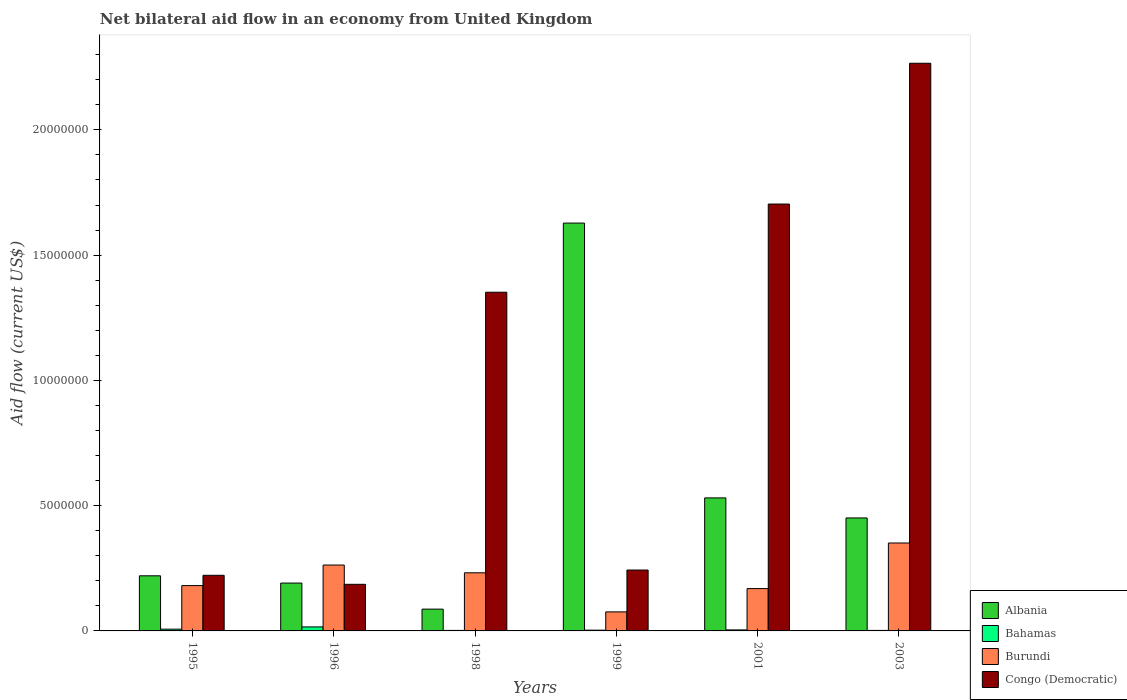How many different coloured bars are there?
Your answer should be compact. 4. Are the number of bars per tick equal to the number of legend labels?
Ensure brevity in your answer.  Yes. Are the number of bars on each tick of the X-axis equal?
Ensure brevity in your answer.  Yes. In how many cases, is the number of bars for a given year not equal to the number of legend labels?
Offer a terse response. 0. What is the net bilateral aid flow in Congo (Democratic) in 1995?
Provide a succinct answer. 2.22e+06. Across all years, what is the maximum net bilateral aid flow in Burundi?
Provide a succinct answer. 3.51e+06. Across all years, what is the minimum net bilateral aid flow in Albania?
Keep it short and to the point. 8.70e+05. In which year was the net bilateral aid flow in Bahamas maximum?
Give a very brief answer. 1996. In which year was the net bilateral aid flow in Burundi minimum?
Offer a terse response. 1999. What is the total net bilateral aid flow in Albania in the graph?
Ensure brevity in your answer.  3.11e+07. What is the difference between the net bilateral aid flow in Bahamas in 1998 and that in 2003?
Your answer should be compact. 0. What is the difference between the net bilateral aid flow in Bahamas in 1998 and the net bilateral aid flow in Congo (Democratic) in 1995?
Give a very brief answer. -2.20e+06. What is the average net bilateral aid flow in Congo (Democratic) per year?
Offer a terse response. 9.96e+06. In the year 1999, what is the difference between the net bilateral aid flow in Congo (Democratic) and net bilateral aid flow in Burundi?
Your answer should be compact. 1.67e+06. In how many years, is the net bilateral aid flow in Congo (Democratic) greater than 18000000 US$?
Your response must be concise. 1. What is the ratio of the net bilateral aid flow in Bahamas in 1999 to that in 2001?
Give a very brief answer. 0.75. Is the net bilateral aid flow in Congo (Democratic) in 1995 less than that in 1996?
Offer a very short reply. No. Is the difference between the net bilateral aid flow in Congo (Democratic) in 1995 and 2001 greater than the difference between the net bilateral aid flow in Burundi in 1995 and 2001?
Give a very brief answer. No. What is the difference between the highest and the lowest net bilateral aid flow in Burundi?
Your answer should be very brief. 2.75e+06. In how many years, is the net bilateral aid flow in Burundi greater than the average net bilateral aid flow in Burundi taken over all years?
Provide a short and direct response. 3. Is the sum of the net bilateral aid flow in Albania in 1995 and 2003 greater than the maximum net bilateral aid flow in Congo (Democratic) across all years?
Make the answer very short. No. What does the 2nd bar from the left in 2003 represents?
Your answer should be very brief. Bahamas. What does the 3rd bar from the right in 1998 represents?
Provide a short and direct response. Bahamas. How many bars are there?
Make the answer very short. 24. Are all the bars in the graph horizontal?
Offer a terse response. No. How many years are there in the graph?
Your response must be concise. 6. What is the difference between two consecutive major ticks on the Y-axis?
Your response must be concise. 5.00e+06. Are the values on the major ticks of Y-axis written in scientific E-notation?
Give a very brief answer. No. Does the graph contain any zero values?
Keep it short and to the point. No. Does the graph contain grids?
Keep it short and to the point. No. What is the title of the graph?
Make the answer very short. Net bilateral aid flow in an economy from United Kingdom. What is the label or title of the X-axis?
Offer a terse response. Years. What is the Aid flow (current US$) of Albania in 1995?
Make the answer very short. 2.20e+06. What is the Aid flow (current US$) of Bahamas in 1995?
Provide a succinct answer. 7.00e+04. What is the Aid flow (current US$) of Burundi in 1995?
Offer a terse response. 1.81e+06. What is the Aid flow (current US$) in Congo (Democratic) in 1995?
Keep it short and to the point. 2.22e+06. What is the Aid flow (current US$) in Albania in 1996?
Offer a very short reply. 1.91e+06. What is the Aid flow (current US$) in Burundi in 1996?
Offer a terse response. 2.63e+06. What is the Aid flow (current US$) in Congo (Democratic) in 1996?
Make the answer very short. 1.86e+06. What is the Aid flow (current US$) of Albania in 1998?
Provide a short and direct response. 8.70e+05. What is the Aid flow (current US$) in Burundi in 1998?
Provide a succinct answer. 2.32e+06. What is the Aid flow (current US$) in Congo (Democratic) in 1998?
Provide a succinct answer. 1.35e+07. What is the Aid flow (current US$) of Albania in 1999?
Ensure brevity in your answer.  1.63e+07. What is the Aid flow (current US$) in Burundi in 1999?
Your response must be concise. 7.60e+05. What is the Aid flow (current US$) of Congo (Democratic) in 1999?
Your response must be concise. 2.43e+06. What is the Aid flow (current US$) of Albania in 2001?
Ensure brevity in your answer.  5.31e+06. What is the Aid flow (current US$) in Bahamas in 2001?
Your answer should be compact. 4.00e+04. What is the Aid flow (current US$) in Burundi in 2001?
Your answer should be compact. 1.69e+06. What is the Aid flow (current US$) of Congo (Democratic) in 2001?
Offer a terse response. 1.70e+07. What is the Aid flow (current US$) of Albania in 2003?
Your answer should be very brief. 4.51e+06. What is the Aid flow (current US$) of Burundi in 2003?
Your answer should be very brief. 3.51e+06. What is the Aid flow (current US$) of Congo (Democratic) in 2003?
Give a very brief answer. 2.27e+07. Across all years, what is the maximum Aid flow (current US$) in Albania?
Provide a short and direct response. 1.63e+07. Across all years, what is the maximum Aid flow (current US$) of Burundi?
Offer a very short reply. 3.51e+06. Across all years, what is the maximum Aid flow (current US$) of Congo (Democratic)?
Provide a short and direct response. 2.27e+07. Across all years, what is the minimum Aid flow (current US$) in Albania?
Your response must be concise. 8.70e+05. Across all years, what is the minimum Aid flow (current US$) of Burundi?
Offer a terse response. 7.60e+05. Across all years, what is the minimum Aid flow (current US$) in Congo (Democratic)?
Give a very brief answer. 1.86e+06. What is the total Aid flow (current US$) in Albania in the graph?
Your response must be concise. 3.11e+07. What is the total Aid flow (current US$) of Bahamas in the graph?
Ensure brevity in your answer.  3.40e+05. What is the total Aid flow (current US$) in Burundi in the graph?
Make the answer very short. 1.27e+07. What is the total Aid flow (current US$) in Congo (Democratic) in the graph?
Offer a very short reply. 5.97e+07. What is the difference between the Aid flow (current US$) in Bahamas in 1995 and that in 1996?
Make the answer very short. -9.00e+04. What is the difference between the Aid flow (current US$) of Burundi in 1995 and that in 1996?
Make the answer very short. -8.20e+05. What is the difference between the Aid flow (current US$) in Congo (Democratic) in 1995 and that in 1996?
Give a very brief answer. 3.60e+05. What is the difference between the Aid flow (current US$) in Albania in 1995 and that in 1998?
Provide a short and direct response. 1.33e+06. What is the difference between the Aid flow (current US$) in Burundi in 1995 and that in 1998?
Ensure brevity in your answer.  -5.10e+05. What is the difference between the Aid flow (current US$) of Congo (Democratic) in 1995 and that in 1998?
Your response must be concise. -1.13e+07. What is the difference between the Aid flow (current US$) in Albania in 1995 and that in 1999?
Keep it short and to the point. -1.41e+07. What is the difference between the Aid flow (current US$) of Bahamas in 1995 and that in 1999?
Give a very brief answer. 4.00e+04. What is the difference between the Aid flow (current US$) in Burundi in 1995 and that in 1999?
Your response must be concise. 1.05e+06. What is the difference between the Aid flow (current US$) in Albania in 1995 and that in 2001?
Offer a very short reply. -3.11e+06. What is the difference between the Aid flow (current US$) in Congo (Democratic) in 1995 and that in 2001?
Your answer should be compact. -1.48e+07. What is the difference between the Aid flow (current US$) of Albania in 1995 and that in 2003?
Provide a succinct answer. -2.31e+06. What is the difference between the Aid flow (current US$) of Bahamas in 1995 and that in 2003?
Your answer should be compact. 5.00e+04. What is the difference between the Aid flow (current US$) in Burundi in 1995 and that in 2003?
Give a very brief answer. -1.70e+06. What is the difference between the Aid flow (current US$) in Congo (Democratic) in 1995 and that in 2003?
Your answer should be very brief. -2.04e+07. What is the difference between the Aid flow (current US$) in Albania in 1996 and that in 1998?
Your answer should be compact. 1.04e+06. What is the difference between the Aid flow (current US$) of Congo (Democratic) in 1996 and that in 1998?
Offer a terse response. -1.17e+07. What is the difference between the Aid flow (current US$) of Albania in 1996 and that in 1999?
Your response must be concise. -1.44e+07. What is the difference between the Aid flow (current US$) of Burundi in 1996 and that in 1999?
Offer a terse response. 1.87e+06. What is the difference between the Aid flow (current US$) of Congo (Democratic) in 1996 and that in 1999?
Offer a very short reply. -5.70e+05. What is the difference between the Aid flow (current US$) of Albania in 1996 and that in 2001?
Provide a short and direct response. -3.40e+06. What is the difference between the Aid flow (current US$) in Burundi in 1996 and that in 2001?
Your answer should be very brief. 9.40e+05. What is the difference between the Aid flow (current US$) in Congo (Democratic) in 1996 and that in 2001?
Give a very brief answer. -1.52e+07. What is the difference between the Aid flow (current US$) in Albania in 1996 and that in 2003?
Give a very brief answer. -2.60e+06. What is the difference between the Aid flow (current US$) in Bahamas in 1996 and that in 2003?
Ensure brevity in your answer.  1.40e+05. What is the difference between the Aid flow (current US$) in Burundi in 1996 and that in 2003?
Your answer should be very brief. -8.80e+05. What is the difference between the Aid flow (current US$) of Congo (Democratic) in 1996 and that in 2003?
Your response must be concise. -2.08e+07. What is the difference between the Aid flow (current US$) of Albania in 1998 and that in 1999?
Provide a short and direct response. -1.54e+07. What is the difference between the Aid flow (current US$) of Burundi in 1998 and that in 1999?
Provide a succinct answer. 1.56e+06. What is the difference between the Aid flow (current US$) in Congo (Democratic) in 1998 and that in 1999?
Keep it short and to the point. 1.11e+07. What is the difference between the Aid flow (current US$) in Albania in 1998 and that in 2001?
Your response must be concise. -4.44e+06. What is the difference between the Aid flow (current US$) of Burundi in 1998 and that in 2001?
Give a very brief answer. 6.30e+05. What is the difference between the Aid flow (current US$) of Congo (Democratic) in 1998 and that in 2001?
Make the answer very short. -3.52e+06. What is the difference between the Aid flow (current US$) of Albania in 1998 and that in 2003?
Your answer should be very brief. -3.64e+06. What is the difference between the Aid flow (current US$) in Bahamas in 1998 and that in 2003?
Offer a very short reply. 0. What is the difference between the Aid flow (current US$) in Burundi in 1998 and that in 2003?
Make the answer very short. -1.19e+06. What is the difference between the Aid flow (current US$) of Congo (Democratic) in 1998 and that in 2003?
Provide a succinct answer. -9.14e+06. What is the difference between the Aid flow (current US$) in Albania in 1999 and that in 2001?
Give a very brief answer. 1.10e+07. What is the difference between the Aid flow (current US$) in Bahamas in 1999 and that in 2001?
Ensure brevity in your answer.  -10000. What is the difference between the Aid flow (current US$) in Burundi in 1999 and that in 2001?
Give a very brief answer. -9.30e+05. What is the difference between the Aid flow (current US$) of Congo (Democratic) in 1999 and that in 2001?
Your answer should be compact. -1.46e+07. What is the difference between the Aid flow (current US$) in Albania in 1999 and that in 2003?
Provide a short and direct response. 1.18e+07. What is the difference between the Aid flow (current US$) of Burundi in 1999 and that in 2003?
Make the answer very short. -2.75e+06. What is the difference between the Aid flow (current US$) of Congo (Democratic) in 1999 and that in 2003?
Keep it short and to the point. -2.02e+07. What is the difference between the Aid flow (current US$) of Albania in 2001 and that in 2003?
Provide a succinct answer. 8.00e+05. What is the difference between the Aid flow (current US$) of Bahamas in 2001 and that in 2003?
Offer a very short reply. 2.00e+04. What is the difference between the Aid flow (current US$) of Burundi in 2001 and that in 2003?
Your answer should be very brief. -1.82e+06. What is the difference between the Aid flow (current US$) in Congo (Democratic) in 2001 and that in 2003?
Your response must be concise. -5.62e+06. What is the difference between the Aid flow (current US$) of Albania in 1995 and the Aid flow (current US$) of Bahamas in 1996?
Keep it short and to the point. 2.04e+06. What is the difference between the Aid flow (current US$) in Albania in 1995 and the Aid flow (current US$) in Burundi in 1996?
Offer a very short reply. -4.30e+05. What is the difference between the Aid flow (current US$) of Bahamas in 1995 and the Aid flow (current US$) of Burundi in 1996?
Keep it short and to the point. -2.56e+06. What is the difference between the Aid flow (current US$) of Bahamas in 1995 and the Aid flow (current US$) of Congo (Democratic) in 1996?
Your response must be concise. -1.79e+06. What is the difference between the Aid flow (current US$) in Burundi in 1995 and the Aid flow (current US$) in Congo (Democratic) in 1996?
Provide a short and direct response. -5.00e+04. What is the difference between the Aid flow (current US$) in Albania in 1995 and the Aid flow (current US$) in Bahamas in 1998?
Your response must be concise. 2.18e+06. What is the difference between the Aid flow (current US$) of Albania in 1995 and the Aid flow (current US$) of Burundi in 1998?
Provide a short and direct response. -1.20e+05. What is the difference between the Aid flow (current US$) in Albania in 1995 and the Aid flow (current US$) in Congo (Democratic) in 1998?
Ensure brevity in your answer.  -1.13e+07. What is the difference between the Aid flow (current US$) in Bahamas in 1995 and the Aid flow (current US$) in Burundi in 1998?
Offer a very short reply. -2.25e+06. What is the difference between the Aid flow (current US$) in Bahamas in 1995 and the Aid flow (current US$) in Congo (Democratic) in 1998?
Your response must be concise. -1.34e+07. What is the difference between the Aid flow (current US$) of Burundi in 1995 and the Aid flow (current US$) of Congo (Democratic) in 1998?
Your answer should be compact. -1.17e+07. What is the difference between the Aid flow (current US$) of Albania in 1995 and the Aid flow (current US$) of Bahamas in 1999?
Keep it short and to the point. 2.17e+06. What is the difference between the Aid flow (current US$) in Albania in 1995 and the Aid flow (current US$) in Burundi in 1999?
Your response must be concise. 1.44e+06. What is the difference between the Aid flow (current US$) of Bahamas in 1995 and the Aid flow (current US$) of Burundi in 1999?
Provide a succinct answer. -6.90e+05. What is the difference between the Aid flow (current US$) in Bahamas in 1995 and the Aid flow (current US$) in Congo (Democratic) in 1999?
Provide a succinct answer. -2.36e+06. What is the difference between the Aid flow (current US$) in Burundi in 1995 and the Aid flow (current US$) in Congo (Democratic) in 1999?
Offer a terse response. -6.20e+05. What is the difference between the Aid flow (current US$) in Albania in 1995 and the Aid flow (current US$) in Bahamas in 2001?
Provide a succinct answer. 2.16e+06. What is the difference between the Aid flow (current US$) in Albania in 1995 and the Aid flow (current US$) in Burundi in 2001?
Give a very brief answer. 5.10e+05. What is the difference between the Aid flow (current US$) of Albania in 1995 and the Aid flow (current US$) of Congo (Democratic) in 2001?
Your answer should be compact. -1.48e+07. What is the difference between the Aid flow (current US$) of Bahamas in 1995 and the Aid flow (current US$) of Burundi in 2001?
Offer a very short reply. -1.62e+06. What is the difference between the Aid flow (current US$) in Bahamas in 1995 and the Aid flow (current US$) in Congo (Democratic) in 2001?
Provide a short and direct response. -1.70e+07. What is the difference between the Aid flow (current US$) of Burundi in 1995 and the Aid flow (current US$) of Congo (Democratic) in 2001?
Offer a very short reply. -1.52e+07. What is the difference between the Aid flow (current US$) in Albania in 1995 and the Aid flow (current US$) in Bahamas in 2003?
Offer a very short reply. 2.18e+06. What is the difference between the Aid flow (current US$) in Albania in 1995 and the Aid flow (current US$) in Burundi in 2003?
Ensure brevity in your answer.  -1.31e+06. What is the difference between the Aid flow (current US$) of Albania in 1995 and the Aid flow (current US$) of Congo (Democratic) in 2003?
Offer a terse response. -2.05e+07. What is the difference between the Aid flow (current US$) in Bahamas in 1995 and the Aid flow (current US$) in Burundi in 2003?
Your answer should be compact. -3.44e+06. What is the difference between the Aid flow (current US$) of Bahamas in 1995 and the Aid flow (current US$) of Congo (Democratic) in 2003?
Give a very brief answer. -2.26e+07. What is the difference between the Aid flow (current US$) of Burundi in 1995 and the Aid flow (current US$) of Congo (Democratic) in 2003?
Keep it short and to the point. -2.08e+07. What is the difference between the Aid flow (current US$) of Albania in 1996 and the Aid flow (current US$) of Bahamas in 1998?
Provide a succinct answer. 1.89e+06. What is the difference between the Aid flow (current US$) in Albania in 1996 and the Aid flow (current US$) in Burundi in 1998?
Your answer should be compact. -4.10e+05. What is the difference between the Aid flow (current US$) of Albania in 1996 and the Aid flow (current US$) of Congo (Democratic) in 1998?
Ensure brevity in your answer.  -1.16e+07. What is the difference between the Aid flow (current US$) in Bahamas in 1996 and the Aid flow (current US$) in Burundi in 1998?
Ensure brevity in your answer.  -2.16e+06. What is the difference between the Aid flow (current US$) in Bahamas in 1996 and the Aid flow (current US$) in Congo (Democratic) in 1998?
Keep it short and to the point. -1.34e+07. What is the difference between the Aid flow (current US$) of Burundi in 1996 and the Aid flow (current US$) of Congo (Democratic) in 1998?
Make the answer very short. -1.09e+07. What is the difference between the Aid flow (current US$) in Albania in 1996 and the Aid flow (current US$) in Bahamas in 1999?
Your answer should be compact. 1.88e+06. What is the difference between the Aid flow (current US$) of Albania in 1996 and the Aid flow (current US$) of Burundi in 1999?
Offer a terse response. 1.15e+06. What is the difference between the Aid flow (current US$) of Albania in 1996 and the Aid flow (current US$) of Congo (Democratic) in 1999?
Provide a succinct answer. -5.20e+05. What is the difference between the Aid flow (current US$) in Bahamas in 1996 and the Aid flow (current US$) in Burundi in 1999?
Offer a very short reply. -6.00e+05. What is the difference between the Aid flow (current US$) of Bahamas in 1996 and the Aid flow (current US$) of Congo (Democratic) in 1999?
Your response must be concise. -2.27e+06. What is the difference between the Aid flow (current US$) of Albania in 1996 and the Aid flow (current US$) of Bahamas in 2001?
Your answer should be very brief. 1.87e+06. What is the difference between the Aid flow (current US$) in Albania in 1996 and the Aid flow (current US$) in Burundi in 2001?
Your answer should be compact. 2.20e+05. What is the difference between the Aid flow (current US$) in Albania in 1996 and the Aid flow (current US$) in Congo (Democratic) in 2001?
Give a very brief answer. -1.51e+07. What is the difference between the Aid flow (current US$) in Bahamas in 1996 and the Aid flow (current US$) in Burundi in 2001?
Your answer should be compact. -1.53e+06. What is the difference between the Aid flow (current US$) of Bahamas in 1996 and the Aid flow (current US$) of Congo (Democratic) in 2001?
Make the answer very short. -1.69e+07. What is the difference between the Aid flow (current US$) of Burundi in 1996 and the Aid flow (current US$) of Congo (Democratic) in 2001?
Offer a very short reply. -1.44e+07. What is the difference between the Aid flow (current US$) in Albania in 1996 and the Aid flow (current US$) in Bahamas in 2003?
Your answer should be very brief. 1.89e+06. What is the difference between the Aid flow (current US$) of Albania in 1996 and the Aid flow (current US$) of Burundi in 2003?
Keep it short and to the point. -1.60e+06. What is the difference between the Aid flow (current US$) in Albania in 1996 and the Aid flow (current US$) in Congo (Democratic) in 2003?
Ensure brevity in your answer.  -2.08e+07. What is the difference between the Aid flow (current US$) of Bahamas in 1996 and the Aid flow (current US$) of Burundi in 2003?
Your answer should be compact. -3.35e+06. What is the difference between the Aid flow (current US$) of Bahamas in 1996 and the Aid flow (current US$) of Congo (Democratic) in 2003?
Offer a very short reply. -2.25e+07. What is the difference between the Aid flow (current US$) of Burundi in 1996 and the Aid flow (current US$) of Congo (Democratic) in 2003?
Provide a short and direct response. -2.00e+07. What is the difference between the Aid flow (current US$) of Albania in 1998 and the Aid flow (current US$) of Bahamas in 1999?
Offer a very short reply. 8.40e+05. What is the difference between the Aid flow (current US$) of Albania in 1998 and the Aid flow (current US$) of Burundi in 1999?
Offer a terse response. 1.10e+05. What is the difference between the Aid flow (current US$) of Albania in 1998 and the Aid flow (current US$) of Congo (Democratic) in 1999?
Give a very brief answer. -1.56e+06. What is the difference between the Aid flow (current US$) of Bahamas in 1998 and the Aid flow (current US$) of Burundi in 1999?
Offer a terse response. -7.40e+05. What is the difference between the Aid flow (current US$) in Bahamas in 1998 and the Aid flow (current US$) in Congo (Democratic) in 1999?
Provide a short and direct response. -2.41e+06. What is the difference between the Aid flow (current US$) in Albania in 1998 and the Aid flow (current US$) in Bahamas in 2001?
Offer a terse response. 8.30e+05. What is the difference between the Aid flow (current US$) in Albania in 1998 and the Aid flow (current US$) in Burundi in 2001?
Make the answer very short. -8.20e+05. What is the difference between the Aid flow (current US$) of Albania in 1998 and the Aid flow (current US$) of Congo (Democratic) in 2001?
Provide a short and direct response. -1.62e+07. What is the difference between the Aid flow (current US$) of Bahamas in 1998 and the Aid flow (current US$) of Burundi in 2001?
Provide a short and direct response. -1.67e+06. What is the difference between the Aid flow (current US$) of Bahamas in 1998 and the Aid flow (current US$) of Congo (Democratic) in 2001?
Offer a very short reply. -1.70e+07. What is the difference between the Aid flow (current US$) in Burundi in 1998 and the Aid flow (current US$) in Congo (Democratic) in 2001?
Make the answer very short. -1.47e+07. What is the difference between the Aid flow (current US$) of Albania in 1998 and the Aid flow (current US$) of Bahamas in 2003?
Keep it short and to the point. 8.50e+05. What is the difference between the Aid flow (current US$) of Albania in 1998 and the Aid flow (current US$) of Burundi in 2003?
Provide a succinct answer. -2.64e+06. What is the difference between the Aid flow (current US$) in Albania in 1998 and the Aid flow (current US$) in Congo (Democratic) in 2003?
Provide a short and direct response. -2.18e+07. What is the difference between the Aid flow (current US$) in Bahamas in 1998 and the Aid flow (current US$) in Burundi in 2003?
Ensure brevity in your answer.  -3.49e+06. What is the difference between the Aid flow (current US$) in Bahamas in 1998 and the Aid flow (current US$) in Congo (Democratic) in 2003?
Give a very brief answer. -2.26e+07. What is the difference between the Aid flow (current US$) in Burundi in 1998 and the Aid flow (current US$) in Congo (Democratic) in 2003?
Offer a terse response. -2.03e+07. What is the difference between the Aid flow (current US$) in Albania in 1999 and the Aid flow (current US$) in Bahamas in 2001?
Provide a succinct answer. 1.62e+07. What is the difference between the Aid flow (current US$) in Albania in 1999 and the Aid flow (current US$) in Burundi in 2001?
Ensure brevity in your answer.  1.46e+07. What is the difference between the Aid flow (current US$) of Albania in 1999 and the Aid flow (current US$) of Congo (Democratic) in 2001?
Provide a succinct answer. -7.60e+05. What is the difference between the Aid flow (current US$) of Bahamas in 1999 and the Aid flow (current US$) of Burundi in 2001?
Give a very brief answer. -1.66e+06. What is the difference between the Aid flow (current US$) of Bahamas in 1999 and the Aid flow (current US$) of Congo (Democratic) in 2001?
Provide a short and direct response. -1.70e+07. What is the difference between the Aid flow (current US$) in Burundi in 1999 and the Aid flow (current US$) in Congo (Democratic) in 2001?
Offer a very short reply. -1.63e+07. What is the difference between the Aid flow (current US$) in Albania in 1999 and the Aid flow (current US$) in Bahamas in 2003?
Your response must be concise. 1.63e+07. What is the difference between the Aid flow (current US$) in Albania in 1999 and the Aid flow (current US$) in Burundi in 2003?
Ensure brevity in your answer.  1.28e+07. What is the difference between the Aid flow (current US$) of Albania in 1999 and the Aid flow (current US$) of Congo (Democratic) in 2003?
Your answer should be compact. -6.38e+06. What is the difference between the Aid flow (current US$) in Bahamas in 1999 and the Aid flow (current US$) in Burundi in 2003?
Offer a terse response. -3.48e+06. What is the difference between the Aid flow (current US$) in Bahamas in 1999 and the Aid flow (current US$) in Congo (Democratic) in 2003?
Give a very brief answer. -2.26e+07. What is the difference between the Aid flow (current US$) of Burundi in 1999 and the Aid flow (current US$) of Congo (Democratic) in 2003?
Ensure brevity in your answer.  -2.19e+07. What is the difference between the Aid flow (current US$) of Albania in 2001 and the Aid flow (current US$) of Bahamas in 2003?
Offer a very short reply. 5.29e+06. What is the difference between the Aid flow (current US$) of Albania in 2001 and the Aid flow (current US$) of Burundi in 2003?
Your answer should be compact. 1.80e+06. What is the difference between the Aid flow (current US$) of Albania in 2001 and the Aid flow (current US$) of Congo (Democratic) in 2003?
Provide a short and direct response. -1.74e+07. What is the difference between the Aid flow (current US$) of Bahamas in 2001 and the Aid flow (current US$) of Burundi in 2003?
Your answer should be compact. -3.47e+06. What is the difference between the Aid flow (current US$) of Bahamas in 2001 and the Aid flow (current US$) of Congo (Democratic) in 2003?
Provide a succinct answer. -2.26e+07. What is the difference between the Aid flow (current US$) in Burundi in 2001 and the Aid flow (current US$) in Congo (Democratic) in 2003?
Give a very brief answer. -2.10e+07. What is the average Aid flow (current US$) of Albania per year?
Your response must be concise. 5.18e+06. What is the average Aid flow (current US$) of Bahamas per year?
Your answer should be very brief. 5.67e+04. What is the average Aid flow (current US$) in Burundi per year?
Offer a very short reply. 2.12e+06. What is the average Aid flow (current US$) in Congo (Democratic) per year?
Your response must be concise. 9.96e+06. In the year 1995, what is the difference between the Aid flow (current US$) in Albania and Aid flow (current US$) in Bahamas?
Offer a terse response. 2.13e+06. In the year 1995, what is the difference between the Aid flow (current US$) in Bahamas and Aid flow (current US$) in Burundi?
Your answer should be very brief. -1.74e+06. In the year 1995, what is the difference between the Aid flow (current US$) of Bahamas and Aid flow (current US$) of Congo (Democratic)?
Offer a terse response. -2.15e+06. In the year 1995, what is the difference between the Aid flow (current US$) in Burundi and Aid flow (current US$) in Congo (Democratic)?
Your answer should be very brief. -4.10e+05. In the year 1996, what is the difference between the Aid flow (current US$) of Albania and Aid flow (current US$) of Bahamas?
Provide a short and direct response. 1.75e+06. In the year 1996, what is the difference between the Aid flow (current US$) in Albania and Aid flow (current US$) in Burundi?
Provide a succinct answer. -7.20e+05. In the year 1996, what is the difference between the Aid flow (current US$) of Albania and Aid flow (current US$) of Congo (Democratic)?
Give a very brief answer. 5.00e+04. In the year 1996, what is the difference between the Aid flow (current US$) in Bahamas and Aid flow (current US$) in Burundi?
Ensure brevity in your answer.  -2.47e+06. In the year 1996, what is the difference between the Aid flow (current US$) in Bahamas and Aid flow (current US$) in Congo (Democratic)?
Your answer should be compact. -1.70e+06. In the year 1996, what is the difference between the Aid flow (current US$) of Burundi and Aid flow (current US$) of Congo (Democratic)?
Give a very brief answer. 7.70e+05. In the year 1998, what is the difference between the Aid flow (current US$) in Albania and Aid flow (current US$) in Bahamas?
Keep it short and to the point. 8.50e+05. In the year 1998, what is the difference between the Aid flow (current US$) of Albania and Aid flow (current US$) of Burundi?
Your answer should be compact. -1.45e+06. In the year 1998, what is the difference between the Aid flow (current US$) of Albania and Aid flow (current US$) of Congo (Democratic)?
Your answer should be compact. -1.26e+07. In the year 1998, what is the difference between the Aid flow (current US$) of Bahamas and Aid flow (current US$) of Burundi?
Ensure brevity in your answer.  -2.30e+06. In the year 1998, what is the difference between the Aid flow (current US$) of Bahamas and Aid flow (current US$) of Congo (Democratic)?
Make the answer very short. -1.35e+07. In the year 1998, what is the difference between the Aid flow (current US$) in Burundi and Aid flow (current US$) in Congo (Democratic)?
Offer a terse response. -1.12e+07. In the year 1999, what is the difference between the Aid flow (current US$) in Albania and Aid flow (current US$) in Bahamas?
Offer a very short reply. 1.62e+07. In the year 1999, what is the difference between the Aid flow (current US$) in Albania and Aid flow (current US$) in Burundi?
Your answer should be compact. 1.55e+07. In the year 1999, what is the difference between the Aid flow (current US$) of Albania and Aid flow (current US$) of Congo (Democratic)?
Your answer should be very brief. 1.38e+07. In the year 1999, what is the difference between the Aid flow (current US$) in Bahamas and Aid flow (current US$) in Burundi?
Your answer should be very brief. -7.30e+05. In the year 1999, what is the difference between the Aid flow (current US$) in Bahamas and Aid flow (current US$) in Congo (Democratic)?
Your response must be concise. -2.40e+06. In the year 1999, what is the difference between the Aid flow (current US$) in Burundi and Aid flow (current US$) in Congo (Democratic)?
Offer a terse response. -1.67e+06. In the year 2001, what is the difference between the Aid flow (current US$) in Albania and Aid flow (current US$) in Bahamas?
Your answer should be compact. 5.27e+06. In the year 2001, what is the difference between the Aid flow (current US$) in Albania and Aid flow (current US$) in Burundi?
Offer a very short reply. 3.62e+06. In the year 2001, what is the difference between the Aid flow (current US$) in Albania and Aid flow (current US$) in Congo (Democratic)?
Offer a terse response. -1.17e+07. In the year 2001, what is the difference between the Aid flow (current US$) in Bahamas and Aid flow (current US$) in Burundi?
Your answer should be compact. -1.65e+06. In the year 2001, what is the difference between the Aid flow (current US$) in Bahamas and Aid flow (current US$) in Congo (Democratic)?
Offer a terse response. -1.70e+07. In the year 2001, what is the difference between the Aid flow (current US$) in Burundi and Aid flow (current US$) in Congo (Democratic)?
Provide a succinct answer. -1.54e+07. In the year 2003, what is the difference between the Aid flow (current US$) of Albania and Aid flow (current US$) of Bahamas?
Give a very brief answer. 4.49e+06. In the year 2003, what is the difference between the Aid flow (current US$) in Albania and Aid flow (current US$) in Burundi?
Give a very brief answer. 1.00e+06. In the year 2003, what is the difference between the Aid flow (current US$) of Albania and Aid flow (current US$) of Congo (Democratic)?
Your answer should be very brief. -1.82e+07. In the year 2003, what is the difference between the Aid flow (current US$) of Bahamas and Aid flow (current US$) of Burundi?
Offer a very short reply. -3.49e+06. In the year 2003, what is the difference between the Aid flow (current US$) in Bahamas and Aid flow (current US$) in Congo (Democratic)?
Offer a terse response. -2.26e+07. In the year 2003, what is the difference between the Aid flow (current US$) of Burundi and Aid flow (current US$) of Congo (Democratic)?
Give a very brief answer. -1.92e+07. What is the ratio of the Aid flow (current US$) in Albania in 1995 to that in 1996?
Your answer should be compact. 1.15. What is the ratio of the Aid flow (current US$) in Bahamas in 1995 to that in 1996?
Give a very brief answer. 0.44. What is the ratio of the Aid flow (current US$) of Burundi in 1995 to that in 1996?
Give a very brief answer. 0.69. What is the ratio of the Aid flow (current US$) in Congo (Democratic) in 1995 to that in 1996?
Make the answer very short. 1.19. What is the ratio of the Aid flow (current US$) in Albania in 1995 to that in 1998?
Provide a short and direct response. 2.53. What is the ratio of the Aid flow (current US$) of Burundi in 1995 to that in 1998?
Provide a succinct answer. 0.78. What is the ratio of the Aid flow (current US$) of Congo (Democratic) in 1995 to that in 1998?
Provide a succinct answer. 0.16. What is the ratio of the Aid flow (current US$) of Albania in 1995 to that in 1999?
Give a very brief answer. 0.14. What is the ratio of the Aid flow (current US$) in Bahamas in 1995 to that in 1999?
Your answer should be very brief. 2.33. What is the ratio of the Aid flow (current US$) of Burundi in 1995 to that in 1999?
Keep it short and to the point. 2.38. What is the ratio of the Aid flow (current US$) in Congo (Democratic) in 1995 to that in 1999?
Your answer should be very brief. 0.91. What is the ratio of the Aid flow (current US$) in Albania in 1995 to that in 2001?
Keep it short and to the point. 0.41. What is the ratio of the Aid flow (current US$) of Burundi in 1995 to that in 2001?
Provide a short and direct response. 1.07. What is the ratio of the Aid flow (current US$) of Congo (Democratic) in 1995 to that in 2001?
Your answer should be very brief. 0.13. What is the ratio of the Aid flow (current US$) of Albania in 1995 to that in 2003?
Make the answer very short. 0.49. What is the ratio of the Aid flow (current US$) of Burundi in 1995 to that in 2003?
Provide a succinct answer. 0.52. What is the ratio of the Aid flow (current US$) of Congo (Democratic) in 1995 to that in 2003?
Offer a very short reply. 0.1. What is the ratio of the Aid flow (current US$) in Albania in 1996 to that in 1998?
Provide a short and direct response. 2.2. What is the ratio of the Aid flow (current US$) of Burundi in 1996 to that in 1998?
Keep it short and to the point. 1.13. What is the ratio of the Aid flow (current US$) of Congo (Democratic) in 1996 to that in 1998?
Offer a terse response. 0.14. What is the ratio of the Aid flow (current US$) in Albania in 1996 to that in 1999?
Offer a very short reply. 0.12. What is the ratio of the Aid flow (current US$) of Bahamas in 1996 to that in 1999?
Provide a succinct answer. 5.33. What is the ratio of the Aid flow (current US$) of Burundi in 1996 to that in 1999?
Provide a succinct answer. 3.46. What is the ratio of the Aid flow (current US$) in Congo (Democratic) in 1996 to that in 1999?
Provide a short and direct response. 0.77. What is the ratio of the Aid flow (current US$) in Albania in 1996 to that in 2001?
Offer a very short reply. 0.36. What is the ratio of the Aid flow (current US$) of Burundi in 1996 to that in 2001?
Provide a short and direct response. 1.56. What is the ratio of the Aid flow (current US$) in Congo (Democratic) in 1996 to that in 2001?
Your answer should be compact. 0.11. What is the ratio of the Aid flow (current US$) in Albania in 1996 to that in 2003?
Your answer should be very brief. 0.42. What is the ratio of the Aid flow (current US$) of Burundi in 1996 to that in 2003?
Ensure brevity in your answer.  0.75. What is the ratio of the Aid flow (current US$) in Congo (Democratic) in 1996 to that in 2003?
Make the answer very short. 0.08. What is the ratio of the Aid flow (current US$) in Albania in 1998 to that in 1999?
Offer a terse response. 0.05. What is the ratio of the Aid flow (current US$) in Burundi in 1998 to that in 1999?
Your answer should be very brief. 3.05. What is the ratio of the Aid flow (current US$) in Congo (Democratic) in 1998 to that in 1999?
Make the answer very short. 5.56. What is the ratio of the Aid flow (current US$) in Albania in 1998 to that in 2001?
Give a very brief answer. 0.16. What is the ratio of the Aid flow (current US$) in Burundi in 1998 to that in 2001?
Offer a very short reply. 1.37. What is the ratio of the Aid flow (current US$) in Congo (Democratic) in 1998 to that in 2001?
Give a very brief answer. 0.79. What is the ratio of the Aid flow (current US$) of Albania in 1998 to that in 2003?
Keep it short and to the point. 0.19. What is the ratio of the Aid flow (current US$) in Bahamas in 1998 to that in 2003?
Offer a terse response. 1. What is the ratio of the Aid flow (current US$) of Burundi in 1998 to that in 2003?
Provide a short and direct response. 0.66. What is the ratio of the Aid flow (current US$) in Congo (Democratic) in 1998 to that in 2003?
Give a very brief answer. 0.6. What is the ratio of the Aid flow (current US$) of Albania in 1999 to that in 2001?
Your answer should be compact. 3.07. What is the ratio of the Aid flow (current US$) of Burundi in 1999 to that in 2001?
Your response must be concise. 0.45. What is the ratio of the Aid flow (current US$) in Congo (Democratic) in 1999 to that in 2001?
Make the answer very short. 0.14. What is the ratio of the Aid flow (current US$) of Albania in 1999 to that in 2003?
Offer a very short reply. 3.61. What is the ratio of the Aid flow (current US$) in Burundi in 1999 to that in 2003?
Your answer should be compact. 0.22. What is the ratio of the Aid flow (current US$) in Congo (Democratic) in 1999 to that in 2003?
Provide a short and direct response. 0.11. What is the ratio of the Aid flow (current US$) in Albania in 2001 to that in 2003?
Your answer should be very brief. 1.18. What is the ratio of the Aid flow (current US$) of Burundi in 2001 to that in 2003?
Your answer should be very brief. 0.48. What is the ratio of the Aid flow (current US$) in Congo (Democratic) in 2001 to that in 2003?
Ensure brevity in your answer.  0.75. What is the difference between the highest and the second highest Aid flow (current US$) of Albania?
Your answer should be compact. 1.10e+07. What is the difference between the highest and the second highest Aid flow (current US$) of Bahamas?
Provide a short and direct response. 9.00e+04. What is the difference between the highest and the second highest Aid flow (current US$) in Burundi?
Your response must be concise. 8.80e+05. What is the difference between the highest and the second highest Aid flow (current US$) of Congo (Democratic)?
Offer a terse response. 5.62e+06. What is the difference between the highest and the lowest Aid flow (current US$) in Albania?
Ensure brevity in your answer.  1.54e+07. What is the difference between the highest and the lowest Aid flow (current US$) of Bahamas?
Give a very brief answer. 1.40e+05. What is the difference between the highest and the lowest Aid flow (current US$) in Burundi?
Provide a short and direct response. 2.75e+06. What is the difference between the highest and the lowest Aid flow (current US$) of Congo (Democratic)?
Your answer should be very brief. 2.08e+07. 